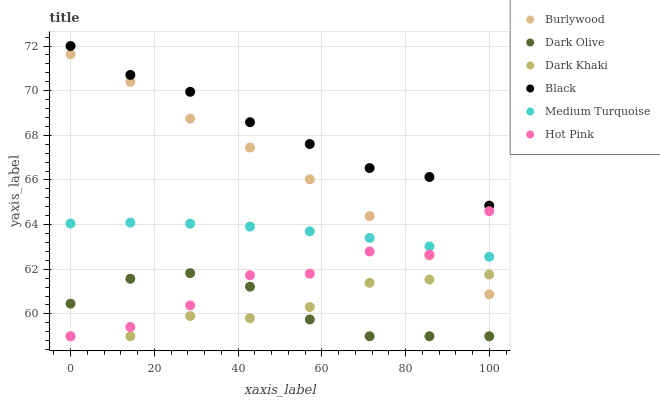Does Dark Olive have the minimum area under the curve?
Answer yes or no. Yes. Does Black have the maximum area under the curve?
Answer yes or no. Yes. Does Burlywood have the minimum area under the curve?
Answer yes or no. No. Does Burlywood have the maximum area under the curve?
Answer yes or no. No. Is Medium Turquoise the smoothest?
Answer yes or no. Yes. Is Hot Pink the roughest?
Answer yes or no. Yes. Is Burlywood the smoothest?
Answer yes or no. No. Is Burlywood the roughest?
Answer yes or no. No. Does Hot Pink have the lowest value?
Answer yes or no. Yes. Does Burlywood have the lowest value?
Answer yes or no. No. Does Black have the highest value?
Answer yes or no. Yes. Does Burlywood have the highest value?
Answer yes or no. No. Is Dark Olive less than Medium Turquoise?
Answer yes or no. Yes. Is Medium Turquoise greater than Dark Khaki?
Answer yes or no. Yes. Does Dark Khaki intersect Dark Olive?
Answer yes or no. Yes. Is Dark Khaki less than Dark Olive?
Answer yes or no. No. Is Dark Khaki greater than Dark Olive?
Answer yes or no. No. Does Dark Olive intersect Medium Turquoise?
Answer yes or no. No. 